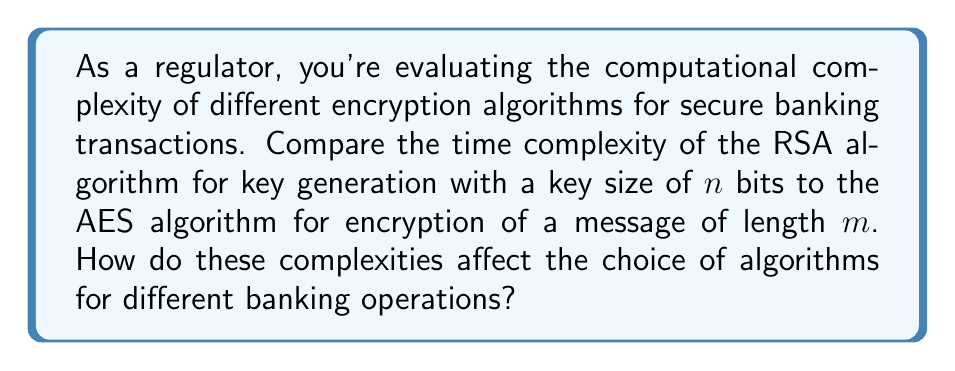Provide a solution to this math problem. Let's break this down step-by-step:

1. RSA Key Generation:
   The time complexity of RSA key generation is approximately $O(n^3)$, where n is the number of bits in the key. This is due to the following steps:
   a) Generating two large prime numbers: $O(n^3)$
   b) Computing their product and Euler's totient function: $O(n^2)$
   c) Finding a suitable public exponent: $O(n)$
   d) Computing the private exponent: $O(n^3)$

2. AES Encryption:
   The time complexity of AES encryption is $O(m)$, where m is the length of the message. This is because:
   a) AES operates on fixed-size blocks (128 bits)
   b) The number of rounds is constant (10, 12, or 14 depending on key size)
   c) Each operation within a round is constant time

3. Comparison:
   - RSA: $O(n^3)$ for key generation
   - AES: $O(m)$ for encryption

4. Impact on banking operations:
   a) For secure communication channels (e.g., HTTPS), AES is preferred due to its linear complexity, allowing for faster encryption/decryption of large amounts of data.
   b) RSA, despite its higher complexity, is used for key exchange and digital signatures due to its asymmetric nature, which is crucial for establishing secure connections and verifying identities.
   c) In practice, a hybrid approach is often used: RSA for initial key exchange, followed by AES for bulk data encryption.

5. Considerations for regulators:
   a) The higher complexity of RSA key generation means it's more computationally intensive, which could impact system performance and energy consumption in large-scale operations.
   b) AES's linear complexity makes it suitable for real-time transactions and processing large volumes of data.
   c) The choice between RSA and AES (or their combination) affects the balance between security, performance, and scalability in banking systems.
Answer: RSA: $O(n^3)$ for key generation; AES: $O(m)$ for encryption. Use hybrid approach: RSA for key exchange, AES for bulk encryption. 